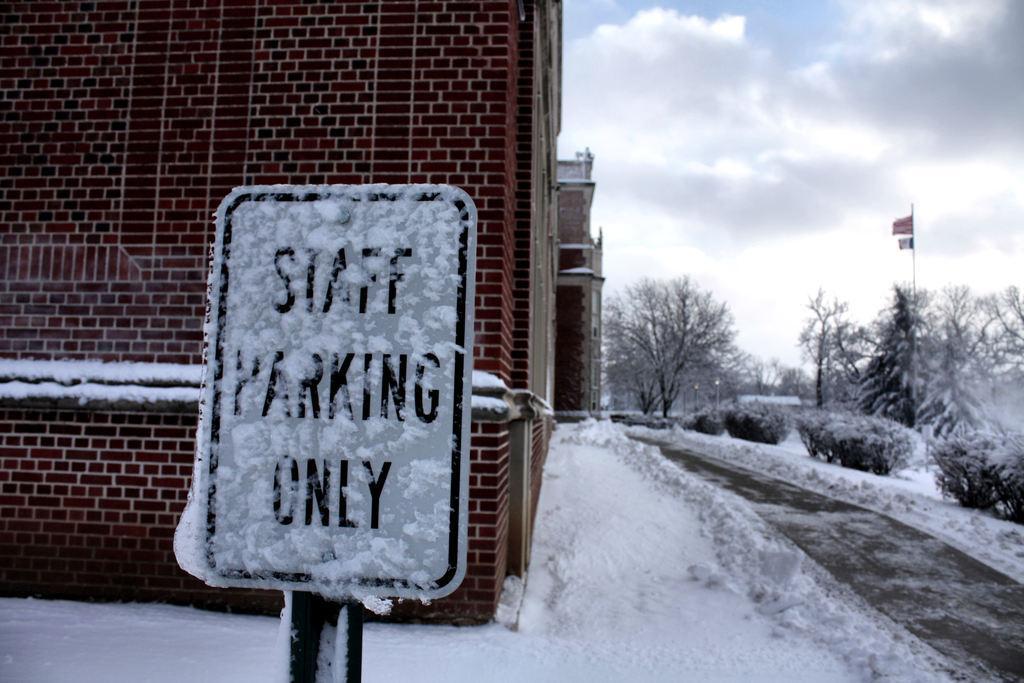How would you summarize this image in a sentence or two? In the background we can see the sky and the clouds. In this picture we can see the trees, plants, flags. On the left side of the picture we can see the buildings. In this picture we can see a sign board with the snow on it. At the bottom portion of the picture we can see the snow. 